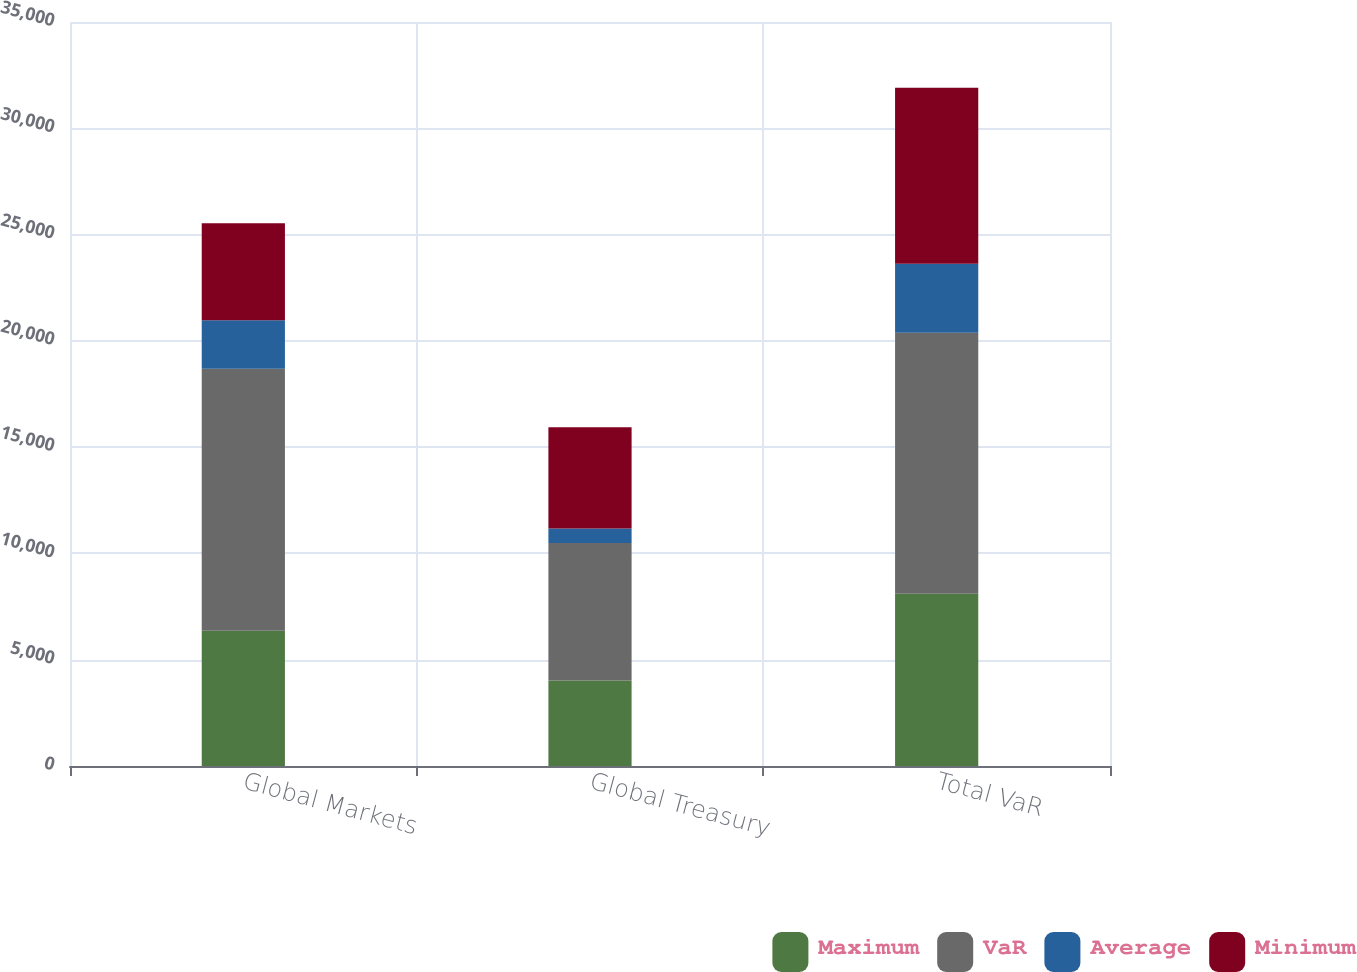Convert chart. <chart><loc_0><loc_0><loc_500><loc_500><stacked_bar_chart><ecel><fcel>Global Markets<fcel>Global Treasury<fcel>Total VaR<nl><fcel>Maximum<fcel>6365<fcel>4027<fcel>8100<nl><fcel>VaR<fcel>12327<fcel>6467<fcel>12278<nl><fcel>Average<fcel>2273<fcel>683<fcel>3244<nl><fcel>Minimum<fcel>4566<fcel>4759<fcel>8281<nl></chart> 